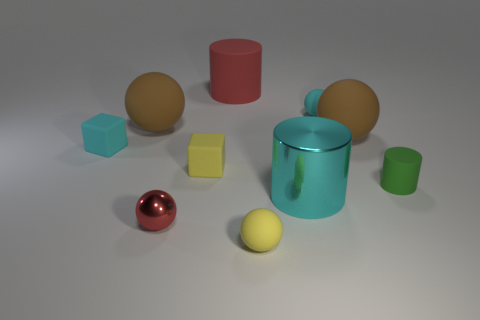Subtract all big metallic cylinders. How many cylinders are left? 2 Subtract all yellow cylinders. How many brown balls are left? 2 Subtract all cyan balls. How many balls are left? 4 Subtract 1 balls. How many balls are left? 4 Subtract all blocks. How many objects are left? 8 Subtract all yellow cylinders. Subtract all red spheres. How many cylinders are left? 3 Subtract all small yellow rubber objects. Subtract all metal objects. How many objects are left? 6 Add 2 tiny metal objects. How many tiny metal objects are left? 3 Add 3 tiny yellow things. How many tiny yellow things exist? 5 Subtract 0 blue balls. How many objects are left? 10 